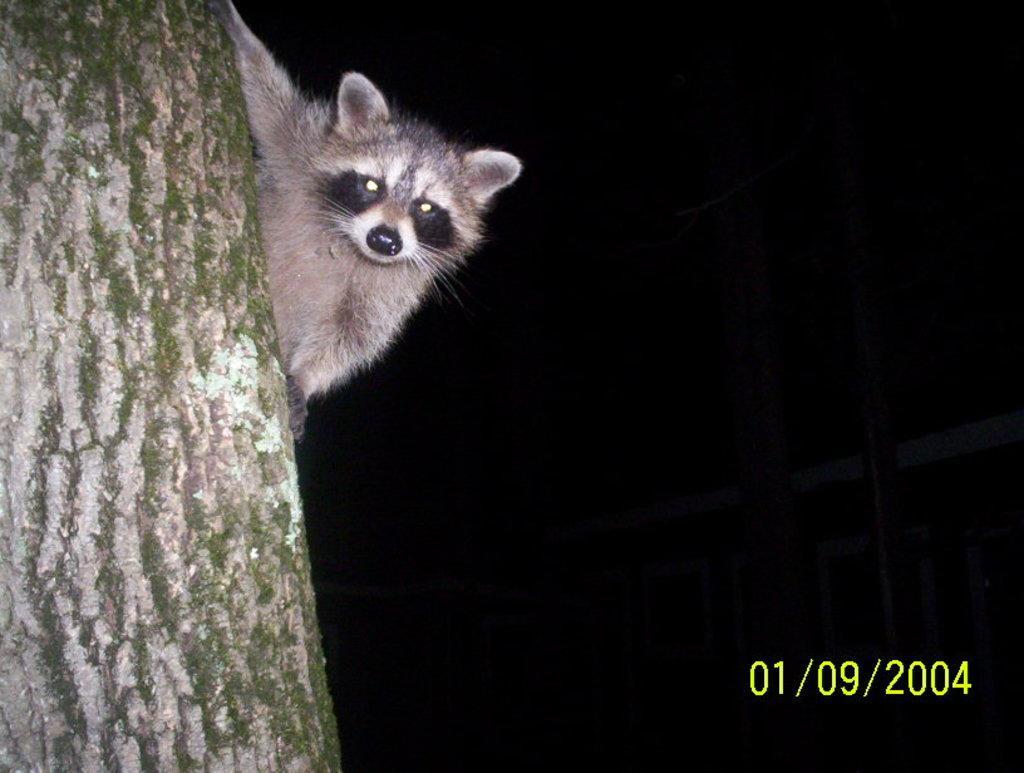Can you describe this image briefly? On the left side of the image there is an animal on the tree. On the right side of the image there is some text. 